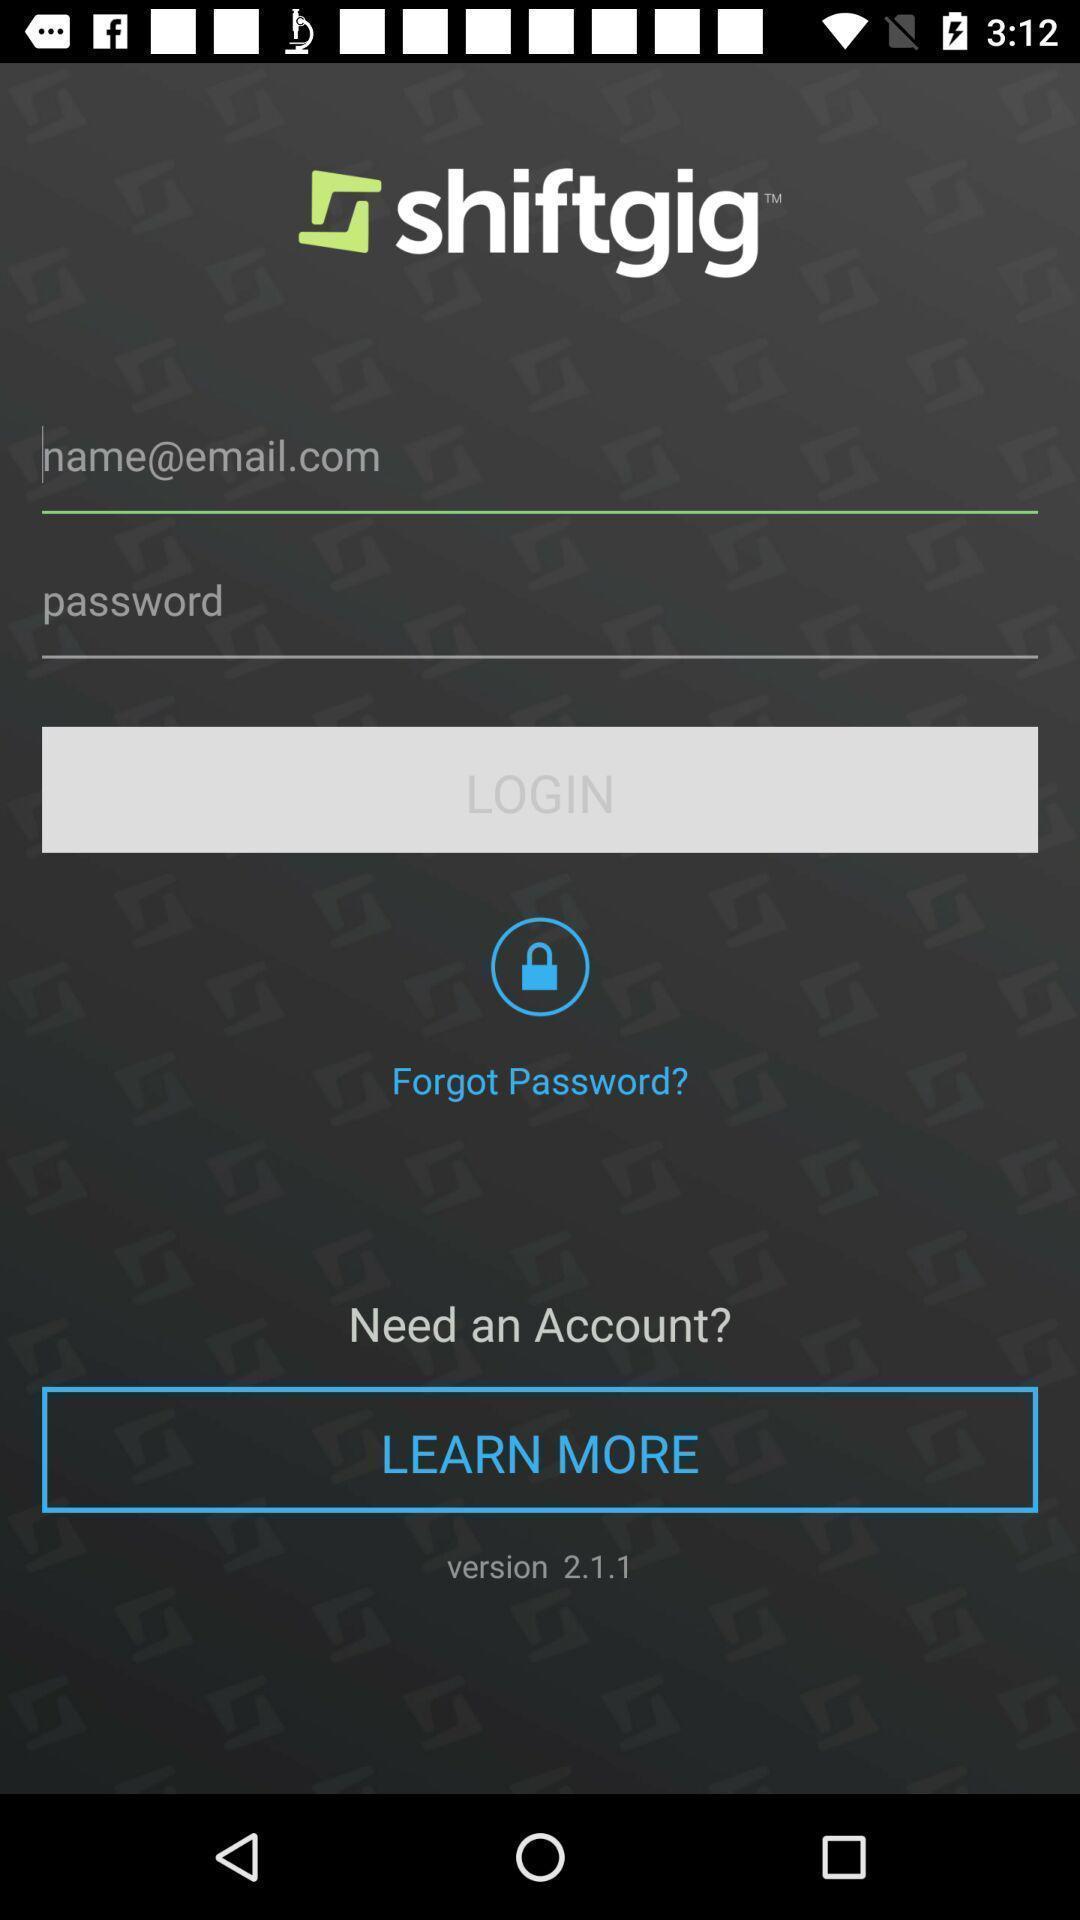Explain the elements present in this screenshot. Screen displaying contents in login page. 